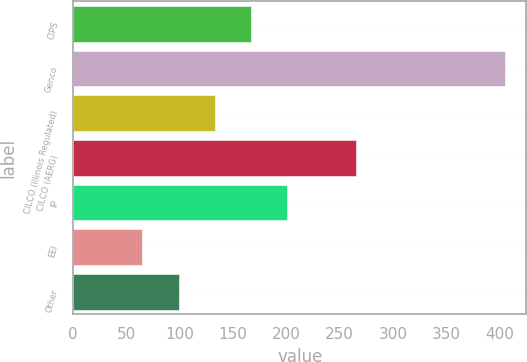Convert chart. <chart><loc_0><loc_0><loc_500><loc_500><bar_chart><fcel>CIPS<fcel>Genco<fcel>CILCO (Illinois Regulated)<fcel>CILCO (AERG)<fcel>IP<fcel>EEI<fcel>Other<nl><fcel>167<fcel>405<fcel>133<fcel>265<fcel>201<fcel>65<fcel>99<nl></chart> 